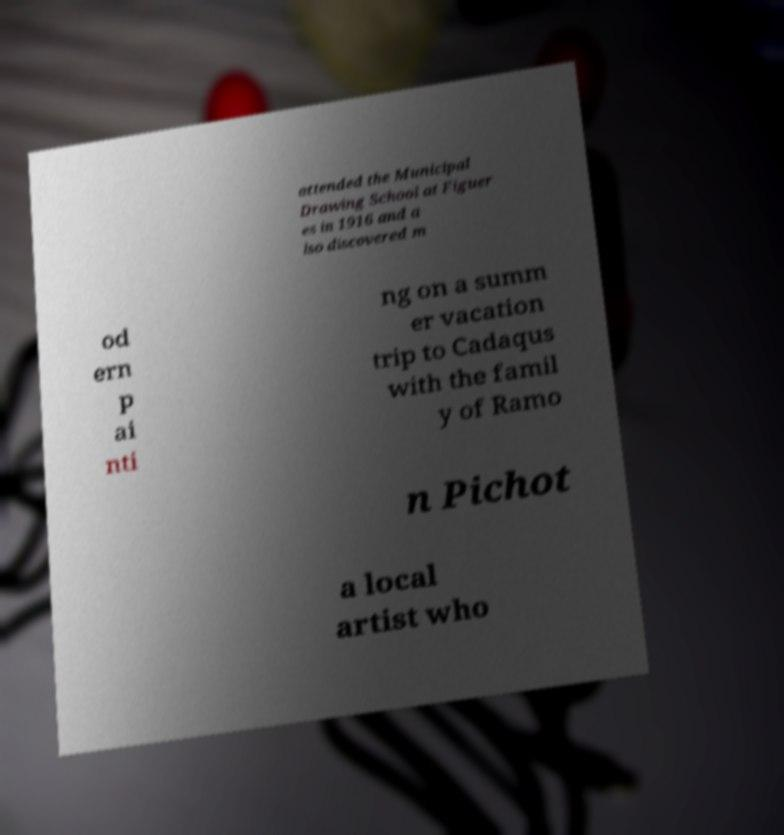Can you read and provide the text displayed in the image?This photo seems to have some interesting text. Can you extract and type it out for me? attended the Municipal Drawing School at Figuer es in 1916 and a lso discovered m od ern p ai nti ng on a summ er vacation trip to Cadaqus with the famil y of Ramo n Pichot a local artist who 